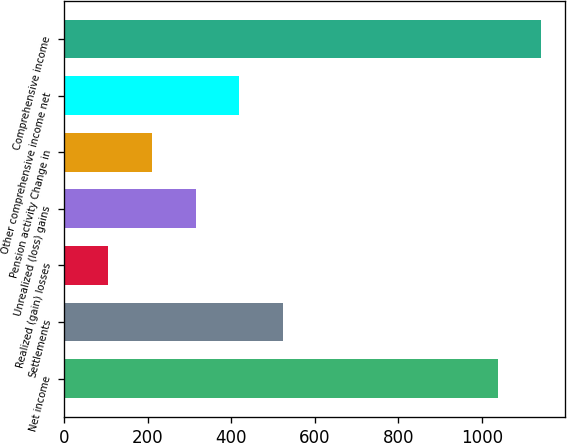Convert chart to OTSL. <chart><loc_0><loc_0><loc_500><loc_500><bar_chart><fcel>Net income<fcel>Settlements<fcel>Realized (gain) losses<fcel>Unrealized (loss) gains<fcel>Pension activity Change in<fcel>Other comprehensive income net<fcel>Comprehensive income<nl><fcel>1037.6<fcel>523.25<fcel>105.21<fcel>314.23<fcel>209.72<fcel>418.74<fcel>1142.11<nl></chart> 